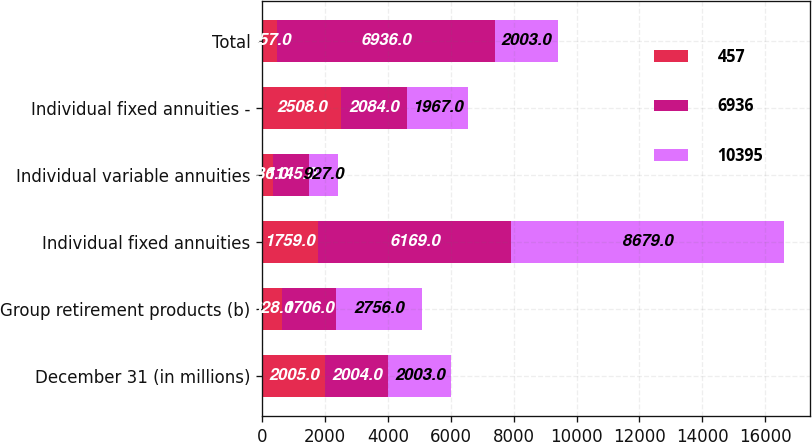Convert chart. <chart><loc_0><loc_0><loc_500><loc_500><stacked_bar_chart><ecel><fcel>December 31 (in millions)<fcel>Group retirement products (b)<fcel>Individual fixed annuities<fcel>Individual variable annuities<fcel>Individual fixed annuities -<fcel>Total<nl><fcel>457<fcel>2005<fcel>628<fcel>1759<fcel>336<fcel>2508<fcel>457<nl><fcel>6936<fcel>2004<fcel>1706<fcel>6169<fcel>1145<fcel>2084<fcel>6936<nl><fcel>10395<fcel>2003<fcel>2756<fcel>8679<fcel>927<fcel>1967<fcel>2003<nl></chart> 